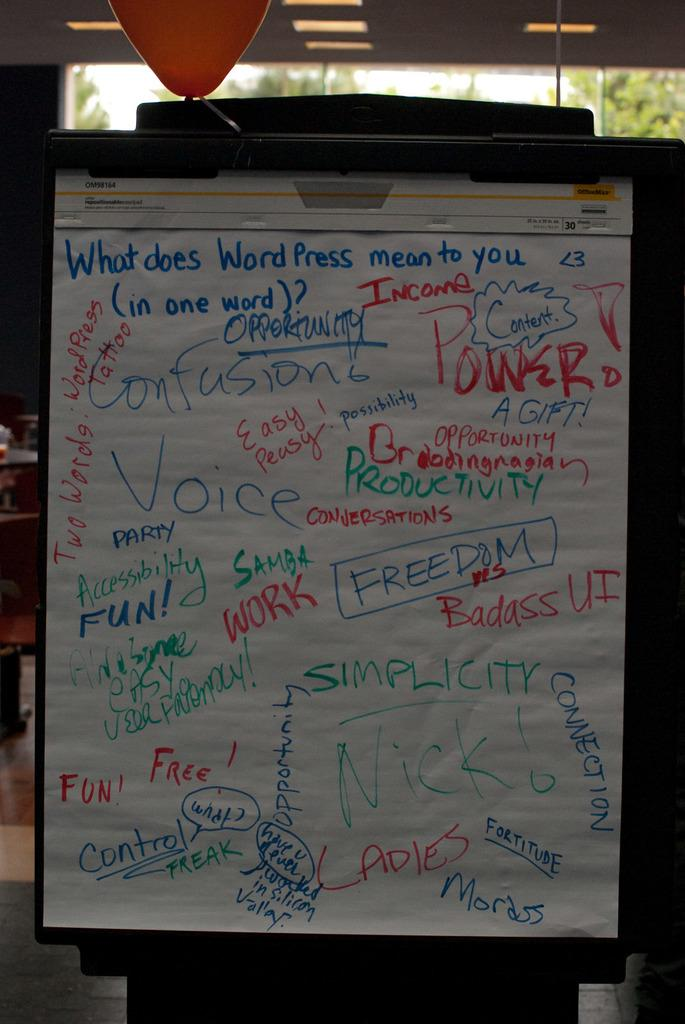<image>
Provide a brief description of the given image. A sheet of paper has words written in red, blue and green ink and one of the words is power. 